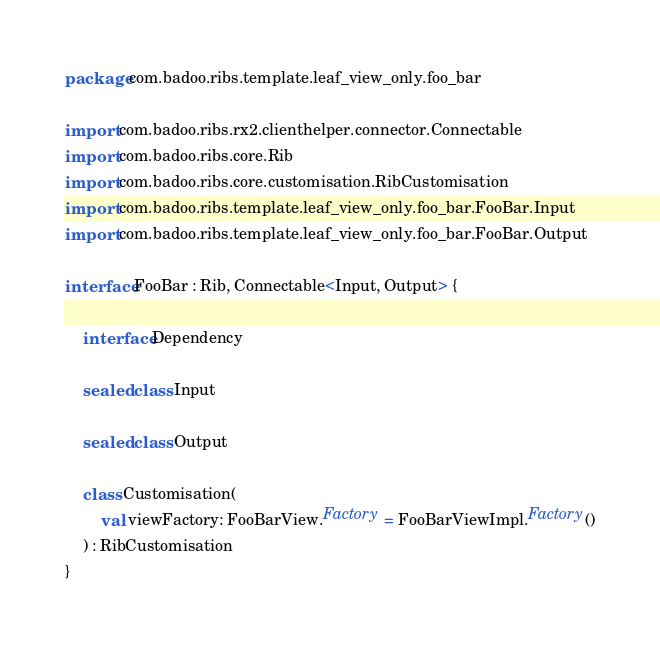Convert code to text. <code><loc_0><loc_0><loc_500><loc_500><_Kotlin_>package com.badoo.ribs.template.leaf_view_only.foo_bar

import com.badoo.ribs.rx2.clienthelper.connector.Connectable
import com.badoo.ribs.core.Rib
import com.badoo.ribs.core.customisation.RibCustomisation
import com.badoo.ribs.template.leaf_view_only.foo_bar.FooBar.Input
import com.badoo.ribs.template.leaf_view_only.foo_bar.FooBar.Output

interface FooBar : Rib, Connectable<Input, Output> {

    interface Dependency

    sealed class Input

    sealed class Output

    class Customisation(
        val viewFactory: FooBarView.Factory = FooBarViewImpl.Factory()
    ) : RibCustomisation
}
</code> 